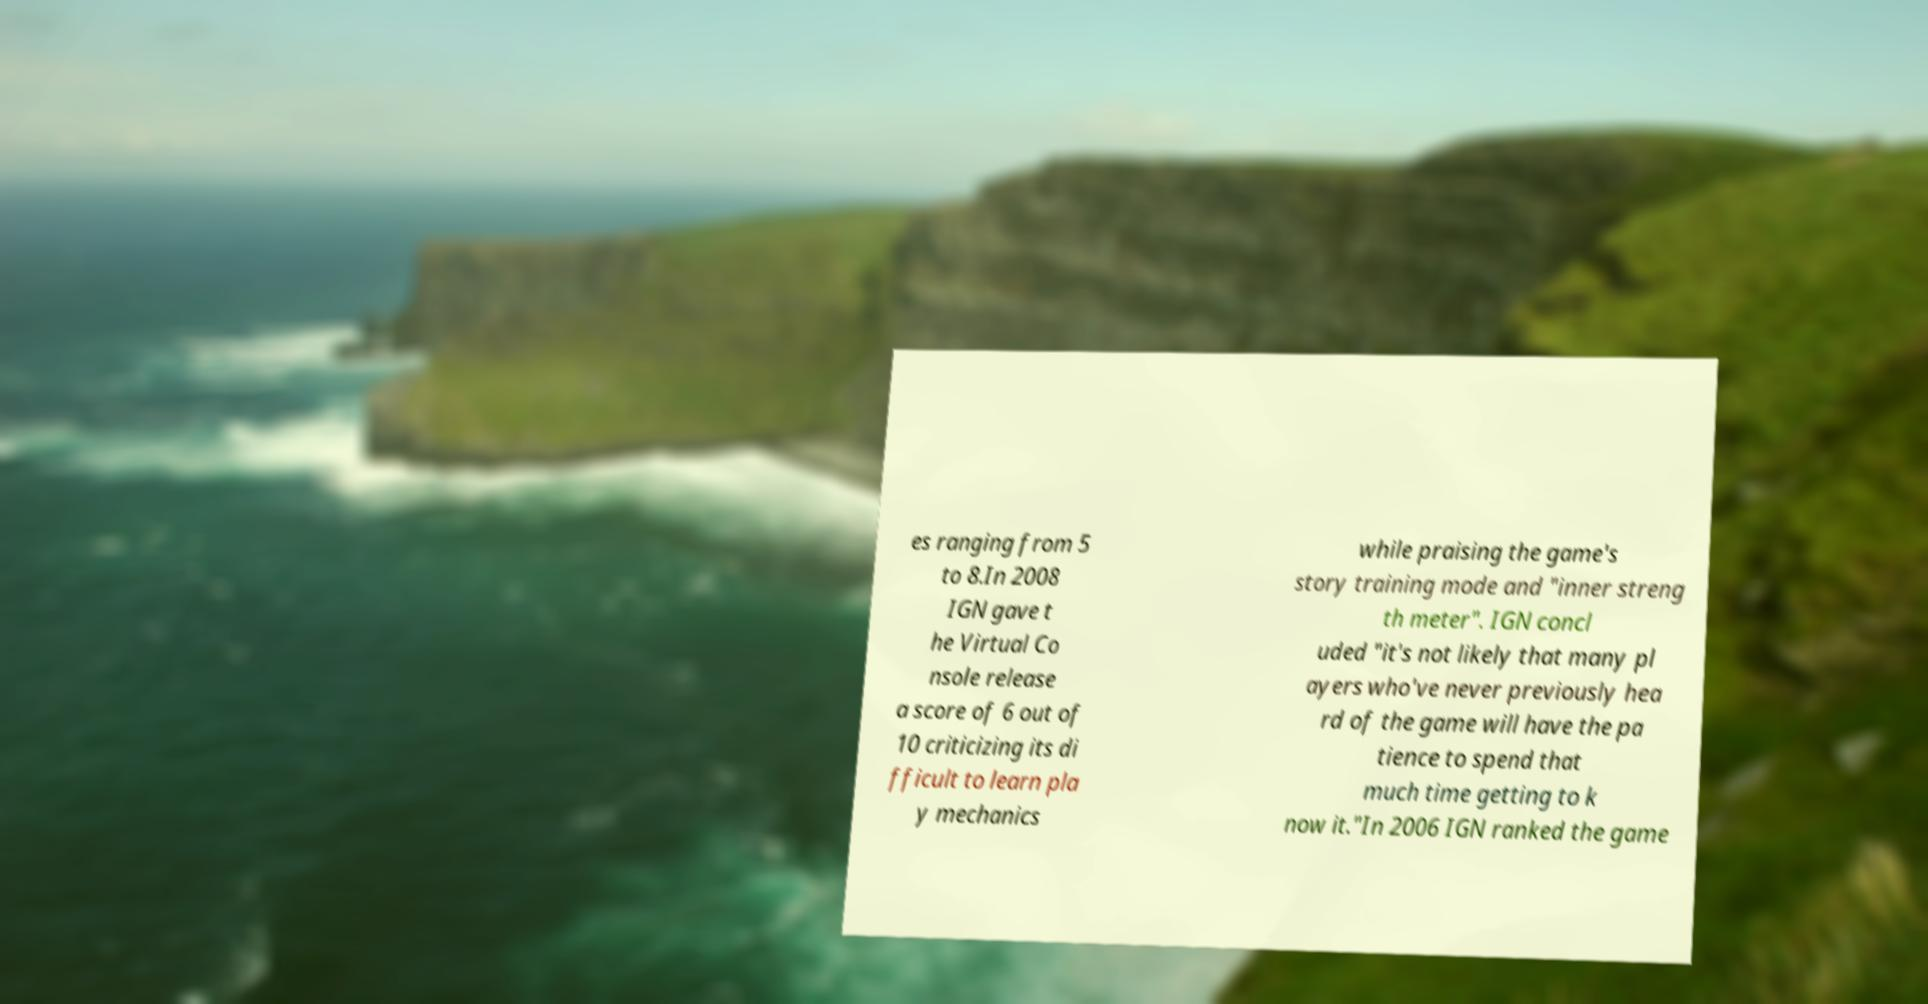Can you read and provide the text displayed in the image?This photo seems to have some interesting text. Can you extract and type it out for me? es ranging from 5 to 8.In 2008 IGN gave t he Virtual Co nsole release a score of 6 out of 10 criticizing its di fficult to learn pla y mechanics while praising the game's story training mode and "inner streng th meter". IGN concl uded "it's not likely that many pl ayers who've never previously hea rd of the game will have the pa tience to spend that much time getting to k now it."In 2006 IGN ranked the game 